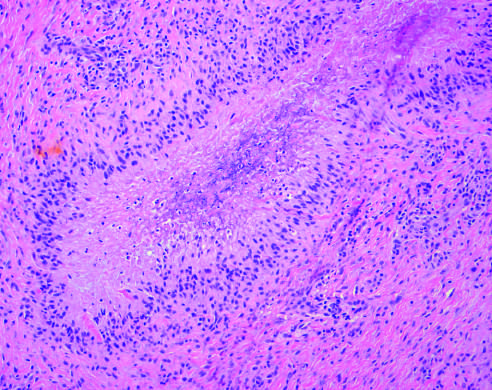s mitotic activity and necrosis rimmed by palisaded histiocytes?
Answer the question using a single word or phrase. No 